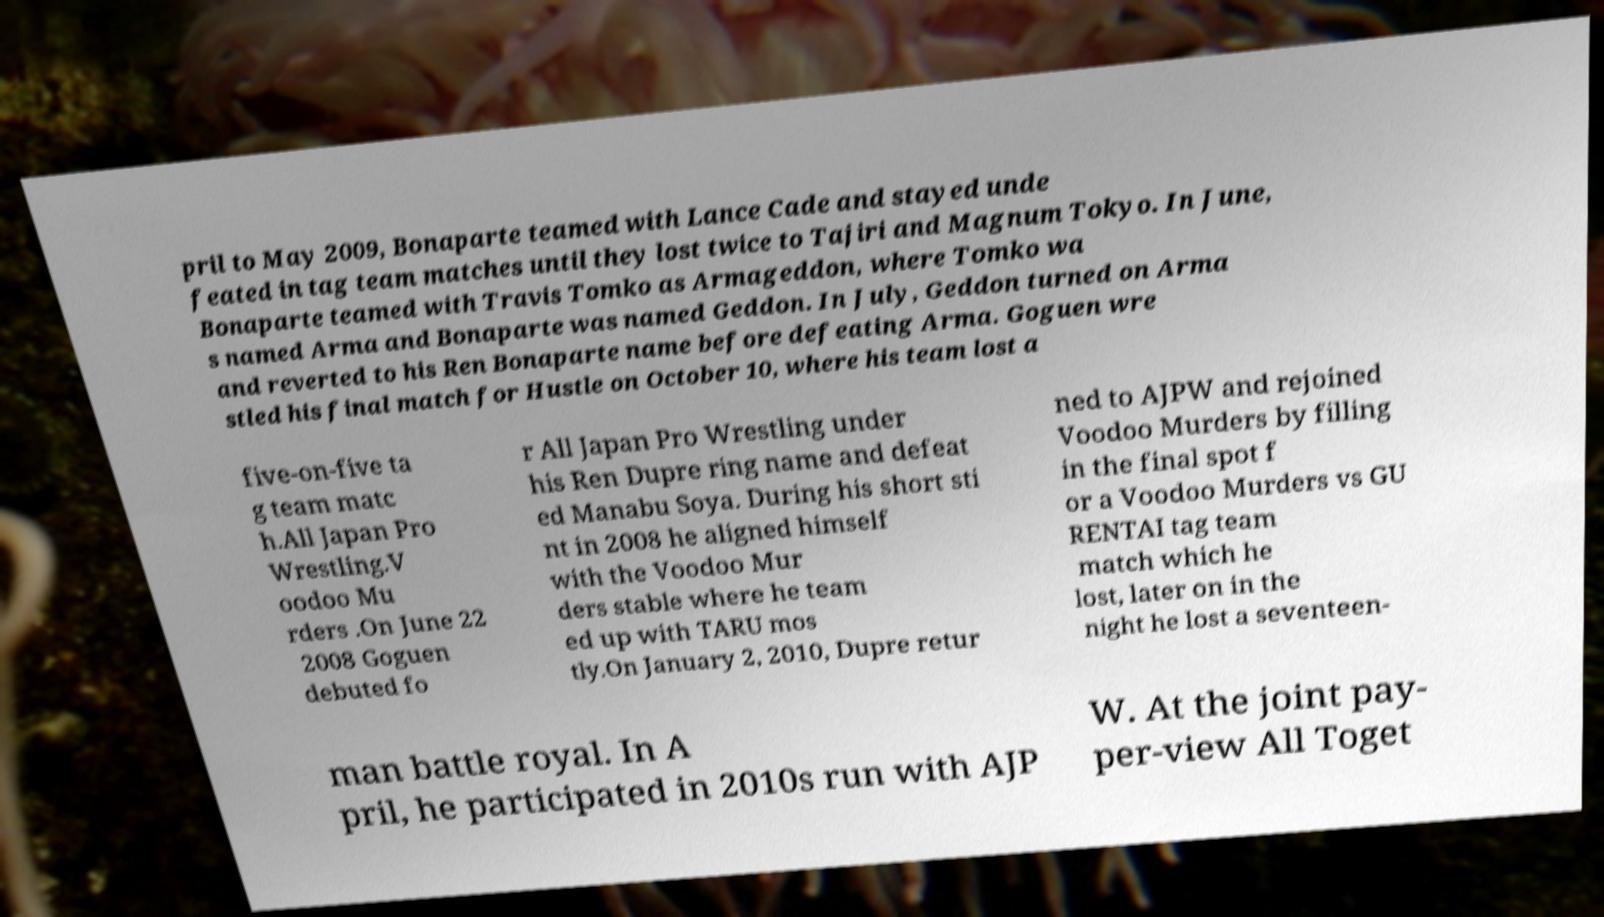What messages or text are displayed in this image? I need them in a readable, typed format. pril to May 2009, Bonaparte teamed with Lance Cade and stayed unde feated in tag team matches until they lost twice to Tajiri and Magnum Tokyo. In June, Bonaparte teamed with Travis Tomko as Armageddon, where Tomko wa s named Arma and Bonaparte was named Geddon. In July, Geddon turned on Arma and reverted to his Ren Bonaparte name before defeating Arma. Goguen wre stled his final match for Hustle on October 10, where his team lost a five-on-five ta g team matc h.All Japan Pro Wrestling.V oodoo Mu rders .On June 22 2008 Goguen debuted fo r All Japan Pro Wrestling under his Ren Dupre ring name and defeat ed Manabu Soya. During his short sti nt in 2008 he aligned himself with the Voodoo Mur ders stable where he team ed up with TARU mos tly.On January 2, 2010, Dupre retur ned to AJPW and rejoined Voodoo Murders by filling in the final spot f or a Voodoo Murders vs GU RENTAI tag team match which he lost, later on in the night he lost a seventeen- man battle royal. In A pril, he participated in 2010s run with AJP W. At the joint pay- per-view All Toget 